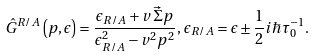<formula> <loc_0><loc_0><loc_500><loc_500>\hat { G } ^ { R / A } \left ( p , \epsilon \right ) = \frac { \epsilon _ { R / A } + v \, \vec { \Sigma } p } { \epsilon _ { R / A } ^ { 2 } - v ^ { 2 } p ^ { 2 } } , \, \epsilon _ { R / A } = \epsilon \pm { \frac { 1 } { 2 } } i \hbar { \tau } _ { 0 } ^ { - 1 } .</formula> 